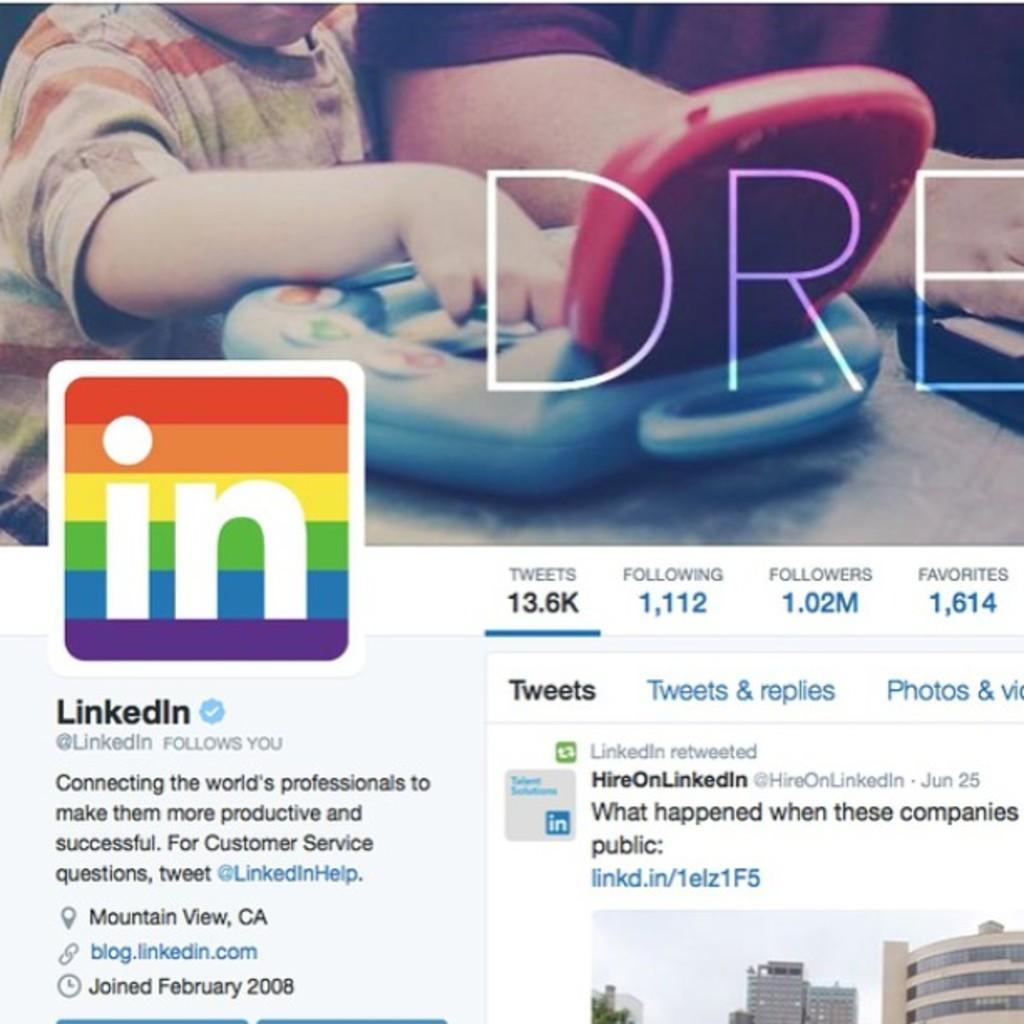What type of page is shown in the image? The image is of a LinkedIn profile page. What visual elements can be seen on the profile page? There are pictures and a logo on the profile page. What type of content is present on the profile page? There is written content on the profile page. What type of clouds can be seen in the background of the profile picture? There is no background or profile picture present in the image; it is a screenshot of a LinkedIn profile page. 